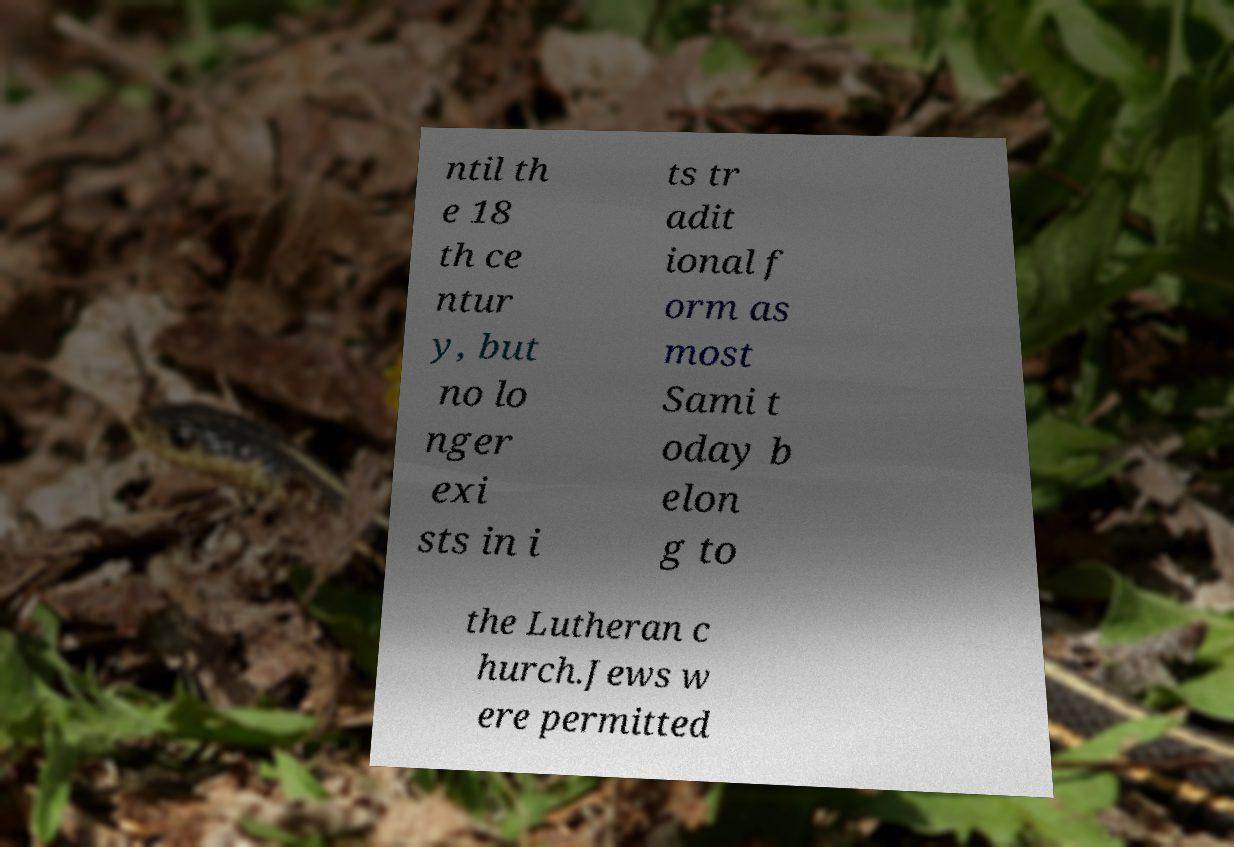There's text embedded in this image that I need extracted. Can you transcribe it verbatim? ntil th e 18 th ce ntur y, but no lo nger exi sts in i ts tr adit ional f orm as most Sami t oday b elon g to the Lutheran c hurch.Jews w ere permitted 